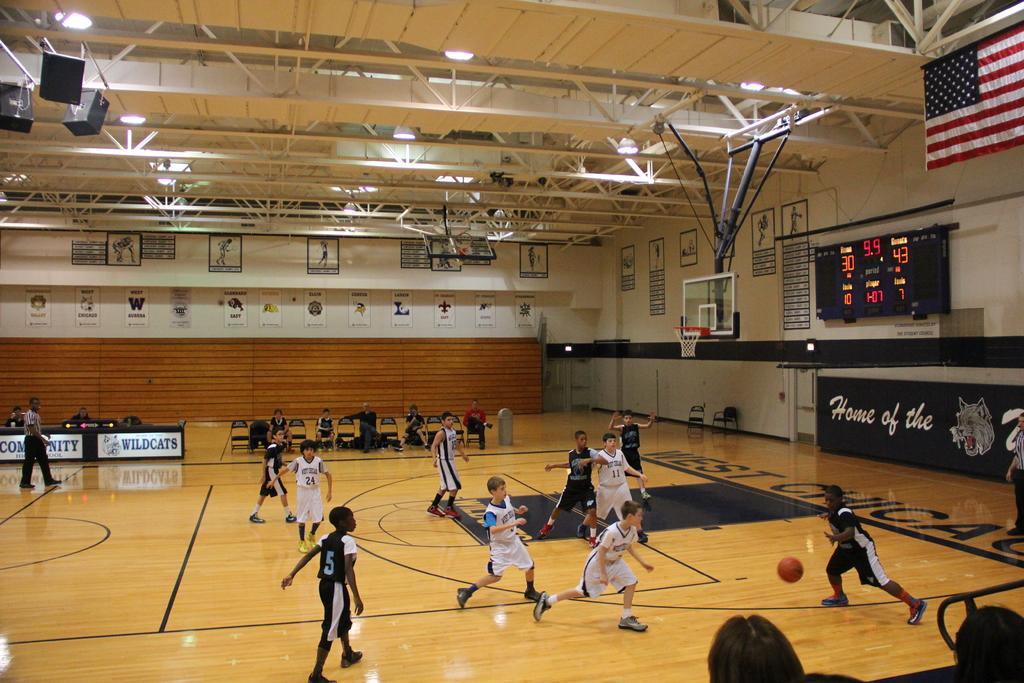How would you summarize this image in a sentence or two? In this image there are group of people playing with a ball inside a stadium, and there are group of people sitting on the chairs, screen , flag, speakers, tables, lights, lighting truss, papers stick to the wall, basketball hoop. 